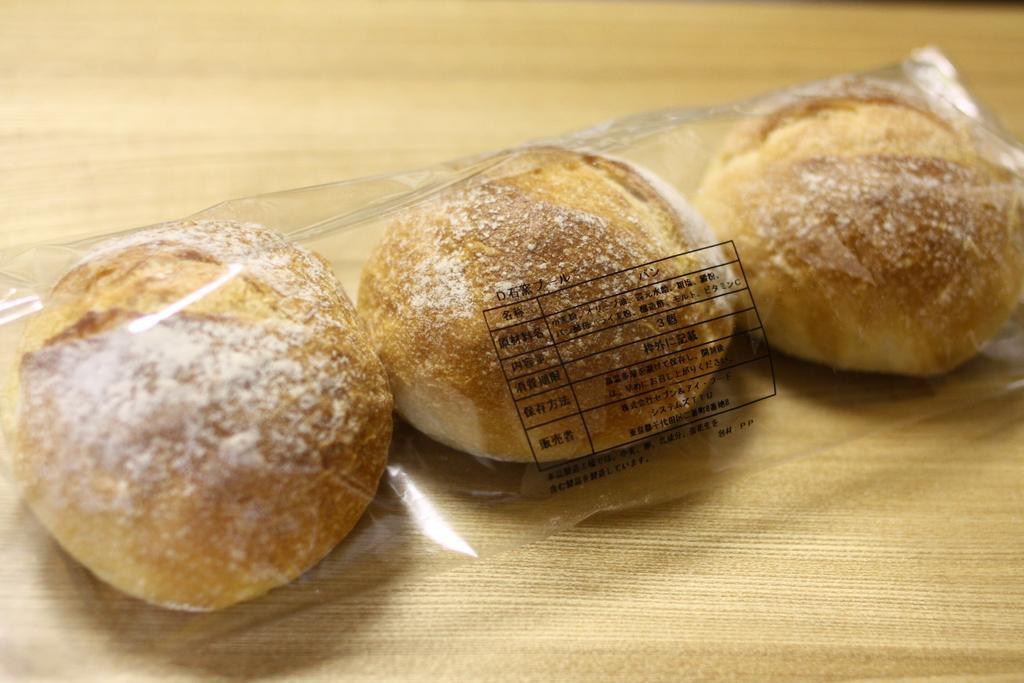Describe this image in one or two sentences. In this picture, we see eatables placed in the plastic cover are placed on the table. This picture is blurred in the background. 